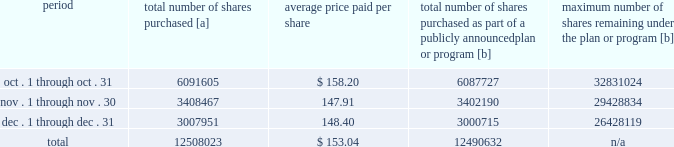Purchases of equity securities 2013 during 2018 , we repurchased 57669746 shares of our common stock at an average price of $ 143.70 .
The table presents common stock repurchases during each month for the fourth quarter of 2018 : period total number of shares purchased [a] average price paid per share total number of shares purchased as part of a publicly announced plan or program [b] maximum number of shares remaining under the plan or program [b] .
[a] total number of shares purchased during the quarter includes approximately 17391 shares delivered or attested to upc by employees to pay stock option exercise prices , satisfy excess tax withholding obligations for stock option exercises or vesting of retention units , and pay withholding obligations for vesting of retention shares .
[b] effective january 1 , 2017 , our board of directors authorized the repurchase of up to 120 million shares of our common stock by december 31 , 2020 .
These repurchases may be made on the open market or through other transactions .
Our management has sole discretion with respect to determining the timing and amount of these transactions. .
What percentage of the total number of shares purchased where purchased in november? 
Computations: (3408467 / 12508023)
Answer: 0.2725. 